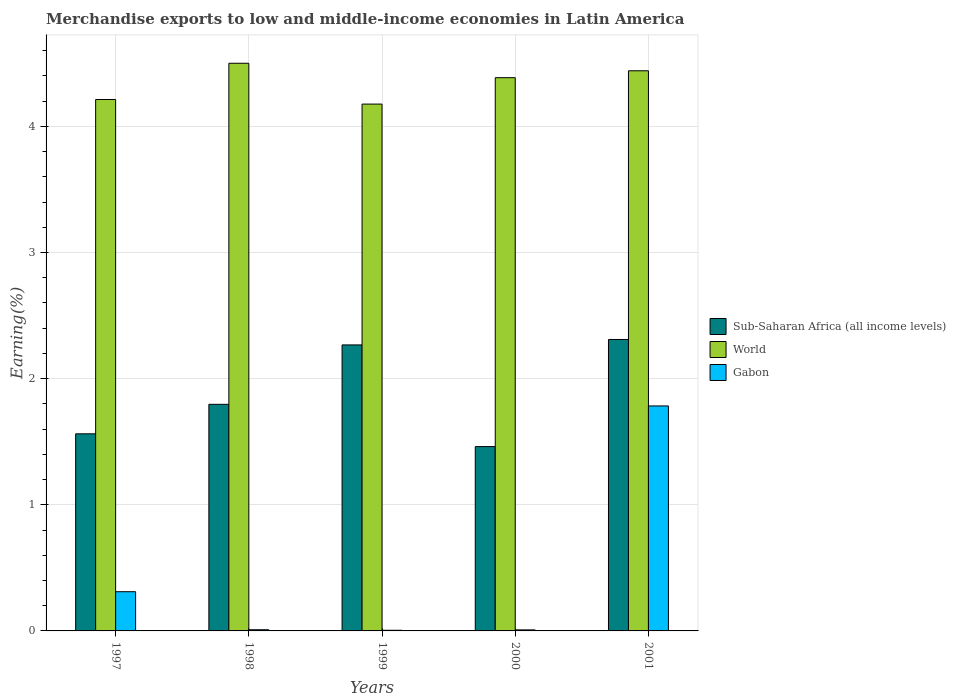How many bars are there on the 2nd tick from the left?
Keep it short and to the point. 3. What is the percentage of amount earned from merchandise exports in Sub-Saharan Africa (all income levels) in 1997?
Offer a terse response. 1.56. Across all years, what is the maximum percentage of amount earned from merchandise exports in World?
Provide a succinct answer. 4.5. Across all years, what is the minimum percentage of amount earned from merchandise exports in Gabon?
Your answer should be very brief. 0.01. In which year was the percentage of amount earned from merchandise exports in World maximum?
Ensure brevity in your answer.  1998. What is the total percentage of amount earned from merchandise exports in World in the graph?
Your answer should be very brief. 21.72. What is the difference between the percentage of amount earned from merchandise exports in World in 1998 and that in 2001?
Provide a succinct answer. 0.06. What is the difference between the percentage of amount earned from merchandise exports in Sub-Saharan Africa (all income levels) in 1998 and the percentage of amount earned from merchandise exports in Gabon in 1999?
Your answer should be compact. 1.79. What is the average percentage of amount earned from merchandise exports in Sub-Saharan Africa (all income levels) per year?
Your answer should be compact. 1.88. In the year 2001, what is the difference between the percentage of amount earned from merchandise exports in Sub-Saharan Africa (all income levels) and percentage of amount earned from merchandise exports in World?
Make the answer very short. -2.13. In how many years, is the percentage of amount earned from merchandise exports in World greater than 1.8 %?
Provide a short and direct response. 5. What is the ratio of the percentage of amount earned from merchandise exports in World in 2000 to that in 2001?
Keep it short and to the point. 0.99. Is the percentage of amount earned from merchandise exports in World in 1999 less than that in 2000?
Keep it short and to the point. Yes. What is the difference between the highest and the second highest percentage of amount earned from merchandise exports in World?
Make the answer very short. 0.06. What is the difference between the highest and the lowest percentage of amount earned from merchandise exports in World?
Offer a terse response. 0.32. Is the sum of the percentage of amount earned from merchandise exports in Gabon in 1998 and 1999 greater than the maximum percentage of amount earned from merchandise exports in World across all years?
Your answer should be compact. No. What does the 3rd bar from the left in 1999 represents?
Ensure brevity in your answer.  Gabon. What does the 1st bar from the right in 2000 represents?
Offer a very short reply. Gabon. How many years are there in the graph?
Your answer should be very brief. 5. What is the difference between two consecutive major ticks on the Y-axis?
Offer a very short reply. 1. Are the values on the major ticks of Y-axis written in scientific E-notation?
Make the answer very short. No. How are the legend labels stacked?
Provide a short and direct response. Vertical. What is the title of the graph?
Offer a terse response. Merchandise exports to low and middle-income economies in Latin America. Does "Europe(developing only)" appear as one of the legend labels in the graph?
Offer a terse response. No. What is the label or title of the Y-axis?
Make the answer very short. Earning(%). What is the Earning(%) of Sub-Saharan Africa (all income levels) in 1997?
Offer a terse response. 1.56. What is the Earning(%) of World in 1997?
Ensure brevity in your answer.  4.21. What is the Earning(%) of Gabon in 1997?
Ensure brevity in your answer.  0.31. What is the Earning(%) in Sub-Saharan Africa (all income levels) in 1998?
Give a very brief answer. 1.8. What is the Earning(%) of World in 1998?
Your response must be concise. 4.5. What is the Earning(%) of Gabon in 1998?
Provide a short and direct response. 0.01. What is the Earning(%) in Sub-Saharan Africa (all income levels) in 1999?
Give a very brief answer. 2.27. What is the Earning(%) of World in 1999?
Provide a succinct answer. 4.18. What is the Earning(%) in Gabon in 1999?
Your response must be concise. 0.01. What is the Earning(%) of Sub-Saharan Africa (all income levels) in 2000?
Keep it short and to the point. 1.46. What is the Earning(%) in World in 2000?
Ensure brevity in your answer.  4.39. What is the Earning(%) of Gabon in 2000?
Ensure brevity in your answer.  0.01. What is the Earning(%) of Sub-Saharan Africa (all income levels) in 2001?
Your answer should be very brief. 2.31. What is the Earning(%) in World in 2001?
Provide a succinct answer. 4.44. What is the Earning(%) of Gabon in 2001?
Provide a short and direct response. 1.78. Across all years, what is the maximum Earning(%) of Sub-Saharan Africa (all income levels)?
Provide a succinct answer. 2.31. Across all years, what is the maximum Earning(%) of World?
Offer a very short reply. 4.5. Across all years, what is the maximum Earning(%) in Gabon?
Your answer should be compact. 1.78. Across all years, what is the minimum Earning(%) in Sub-Saharan Africa (all income levels)?
Your answer should be compact. 1.46. Across all years, what is the minimum Earning(%) of World?
Your answer should be very brief. 4.18. Across all years, what is the minimum Earning(%) in Gabon?
Your response must be concise. 0.01. What is the total Earning(%) in Sub-Saharan Africa (all income levels) in the graph?
Provide a succinct answer. 9.4. What is the total Earning(%) of World in the graph?
Provide a succinct answer. 21.72. What is the total Earning(%) in Gabon in the graph?
Make the answer very short. 2.12. What is the difference between the Earning(%) of Sub-Saharan Africa (all income levels) in 1997 and that in 1998?
Make the answer very short. -0.23. What is the difference between the Earning(%) in World in 1997 and that in 1998?
Provide a short and direct response. -0.29. What is the difference between the Earning(%) in Gabon in 1997 and that in 1998?
Provide a short and direct response. 0.3. What is the difference between the Earning(%) in Sub-Saharan Africa (all income levels) in 1997 and that in 1999?
Your answer should be very brief. -0.7. What is the difference between the Earning(%) in World in 1997 and that in 1999?
Give a very brief answer. 0.04. What is the difference between the Earning(%) of Gabon in 1997 and that in 1999?
Keep it short and to the point. 0.31. What is the difference between the Earning(%) of Sub-Saharan Africa (all income levels) in 1997 and that in 2000?
Keep it short and to the point. 0.1. What is the difference between the Earning(%) of World in 1997 and that in 2000?
Offer a terse response. -0.17. What is the difference between the Earning(%) in Gabon in 1997 and that in 2000?
Your response must be concise. 0.3. What is the difference between the Earning(%) in Sub-Saharan Africa (all income levels) in 1997 and that in 2001?
Your answer should be compact. -0.75. What is the difference between the Earning(%) of World in 1997 and that in 2001?
Ensure brevity in your answer.  -0.23. What is the difference between the Earning(%) in Gabon in 1997 and that in 2001?
Your answer should be very brief. -1.47. What is the difference between the Earning(%) of Sub-Saharan Africa (all income levels) in 1998 and that in 1999?
Keep it short and to the point. -0.47. What is the difference between the Earning(%) in World in 1998 and that in 1999?
Offer a terse response. 0.32. What is the difference between the Earning(%) of Gabon in 1998 and that in 1999?
Your answer should be very brief. 0. What is the difference between the Earning(%) in Sub-Saharan Africa (all income levels) in 1998 and that in 2000?
Keep it short and to the point. 0.34. What is the difference between the Earning(%) of World in 1998 and that in 2000?
Offer a terse response. 0.11. What is the difference between the Earning(%) in Gabon in 1998 and that in 2000?
Offer a terse response. 0. What is the difference between the Earning(%) in Sub-Saharan Africa (all income levels) in 1998 and that in 2001?
Offer a terse response. -0.51. What is the difference between the Earning(%) in World in 1998 and that in 2001?
Offer a very short reply. 0.06. What is the difference between the Earning(%) of Gabon in 1998 and that in 2001?
Your response must be concise. -1.77. What is the difference between the Earning(%) of Sub-Saharan Africa (all income levels) in 1999 and that in 2000?
Make the answer very short. 0.81. What is the difference between the Earning(%) in World in 1999 and that in 2000?
Provide a succinct answer. -0.21. What is the difference between the Earning(%) of Gabon in 1999 and that in 2000?
Your answer should be compact. -0. What is the difference between the Earning(%) in Sub-Saharan Africa (all income levels) in 1999 and that in 2001?
Make the answer very short. -0.04. What is the difference between the Earning(%) in World in 1999 and that in 2001?
Give a very brief answer. -0.26. What is the difference between the Earning(%) of Gabon in 1999 and that in 2001?
Your answer should be very brief. -1.78. What is the difference between the Earning(%) of Sub-Saharan Africa (all income levels) in 2000 and that in 2001?
Offer a very short reply. -0.85. What is the difference between the Earning(%) of World in 2000 and that in 2001?
Your response must be concise. -0.05. What is the difference between the Earning(%) in Gabon in 2000 and that in 2001?
Provide a succinct answer. -1.78. What is the difference between the Earning(%) in Sub-Saharan Africa (all income levels) in 1997 and the Earning(%) in World in 1998?
Your answer should be compact. -2.94. What is the difference between the Earning(%) of Sub-Saharan Africa (all income levels) in 1997 and the Earning(%) of Gabon in 1998?
Give a very brief answer. 1.55. What is the difference between the Earning(%) of World in 1997 and the Earning(%) of Gabon in 1998?
Your response must be concise. 4.2. What is the difference between the Earning(%) of Sub-Saharan Africa (all income levels) in 1997 and the Earning(%) of World in 1999?
Your answer should be very brief. -2.61. What is the difference between the Earning(%) in Sub-Saharan Africa (all income levels) in 1997 and the Earning(%) in Gabon in 1999?
Your response must be concise. 1.56. What is the difference between the Earning(%) of World in 1997 and the Earning(%) of Gabon in 1999?
Keep it short and to the point. 4.21. What is the difference between the Earning(%) in Sub-Saharan Africa (all income levels) in 1997 and the Earning(%) in World in 2000?
Make the answer very short. -2.82. What is the difference between the Earning(%) of Sub-Saharan Africa (all income levels) in 1997 and the Earning(%) of Gabon in 2000?
Provide a succinct answer. 1.55. What is the difference between the Earning(%) in World in 1997 and the Earning(%) in Gabon in 2000?
Offer a terse response. 4.2. What is the difference between the Earning(%) of Sub-Saharan Africa (all income levels) in 1997 and the Earning(%) of World in 2001?
Give a very brief answer. -2.88. What is the difference between the Earning(%) of Sub-Saharan Africa (all income levels) in 1997 and the Earning(%) of Gabon in 2001?
Keep it short and to the point. -0.22. What is the difference between the Earning(%) of World in 1997 and the Earning(%) of Gabon in 2001?
Keep it short and to the point. 2.43. What is the difference between the Earning(%) of Sub-Saharan Africa (all income levels) in 1998 and the Earning(%) of World in 1999?
Your answer should be very brief. -2.38. What is the difference between the Earning(%) in Sub-Saharan Africa (all income levels) in 1998 and the Earning(%) in Gabon in 1999?
Ensure brevity in your answer.  1.79. What is the difference between the Earning(%) in World in 1998 and the Earning(%) in Gabon in 1999?
Ensure brevity in your answer.  4.5. What is the difference between the Earning(%) in Sub-Saharan Africa (all income levels) in 1998 and the Earning(%) in World in 2000?
Your answer should be very brief. -2.59. What is the difference between the Earning(%) in Sub-Saharan Africa (all income levels) in 1998 and the Earning(%) in Gabon in 2000?
Offer a very short reply. 1.79. What is the difference between the Earning(%) in World in 1998 and the Earning(%) in Gabon in 2000?
Ensure brevity in your answer.  4.49. What is the difference between the Earning(%) in Sub-Saharan Africa (all income levels) in 1998 and the Earning(%) in World in 2001?
Offer a terse response. -2.64. What is the difference between the Earning(%) of Sub-Saharan Africa (all income levels) in 1998 and the Earning(%) of Gabon in 2001?
Offer a terse response. 0.01. What is the difference between the Earning(%) of World in 1998 and the Earning(%) of Gabon in 2001?
Your answer should be compact. 2.72. What is the difference between the Earning(%) in Sub-Saharan Africa (all income levels) in 1999 and the Earning(%) in World in 2000?
Provide a short and direct response. -2.12. What is the difference between the Earning(%) of Sub-Saharan Africa (all income levels) in 1999 and the Earning(%) of Gabon in 2000?
Provide a succinct answer. 2.26. What is the difference between the Earning(%) of World in 1999 and the Earning(%) of Gabon in 2000?
Your answer should be compact. 4.17. What is the difference between the Earning(%) in Sub-Saharan Africa (all income levels) in 1999 and the Earning(%) in World in 2001?
Provide a short and direct response. -2.17. What is the difference between the Earning(%) of Sub-Saharan Africa (all income levels) in 1999 and the Earning(%) of Gabon in 2001?
Your response must be concise. 0.48. What is the difference between the Earning(%) in World in 1999 and the Earning(%) in Gabon in 2001?
Offer a very short reply. 2.39. What is the difference between the Earning(%) in Sub-Saharan Africa (all income levels) in 2000 and the Earning(%) in World in 2001?
Keep it short and to the point. -2.98. What is the difference between the Earning(%) in Sub-Saharan Africa (all income levels) in 2000 and the Earning(%) in Gabon in 2001?
Make the answer very short. -0.32. What is the difference between the Earning(%) of World in 2000 and the Earning(%) of Gabon in 2001?
Ensure brevity in your answer.  2.6. What is the average Earning(%) of Sub-Saharan Africa (all income levels) per year?
Keep it short and to the point. 1.88. What is the average Earning(%) of World per year?
Provide a succinct answer. 4.34. What is the average Earning(%) in Gabon per year?
Keep it short and to the point. 0.42. In the year 1997, what is the difference between the Earning(%) of Sub-Saharan Africa (all income levels) and Earning(%) of World?
Offer a terse response. -2.65. In the year 1997, what is the difference between the Earning(%) of Sub-Saharan Africa (all income levels) and Earning(%) of Gabon?
Offer a very short reply. 1.25. In the year 1997, what is the difference between the Earning(%) of World and Earning(%) of Gabon?
Keep it short and to the point. 3.9. In the year 1998, what is the difference between the Earning(%) in Sub-Saharan Africa (all income levels) and Earning(%) in World?
Offer a very short reply. -2.7. In the year 1998, what is the difference between the Earning(%) of Sub-Saharan Africa (all income levels) and Earning(%) of Gabon?
Make the answer very short. 1.79. In the year 1998, what is the difference between the Earning(%) of World and Earning(%) of Gabon?
Your answer should be very brief. 4.49. In the year 1999, what is the difference between the Earning(%) in Sub-Saharan Africa (all income levels) and Earning(%) in World?
Offer a very short reply. -1.91. In the year 1999, what is the difference between the Earning(%) in Sub-Saharan Africa (all income levels) and Earning(%) in Gabon?
Provide a succinct answer. 2.26. In the year 1999, what is the difference between the Earning(%) of World and Earning(%) of Gabon?
Your response must be concise. 4.17. In the year 2000, what is the difference between the Earning(%) in Sub-Saharan Africa (all income levels) and Earning(%) in World?
Keep it short and to the point. -2.92. In the year 2000, what is the difference between the Earning(%) in Sub-Saharan Africa (all income levels) and Earning(%) in Gabon?
Offer a very short reply. 1.45. In the year 2000, what is the difference between the Earning(%) in World and Earning(%) in Gabon?
Ensure brevity in your answer.  4.38. In the year 2001, what is the difference between the Earning(%) in Sub-Saharan Africa (all income levels) and Earning(%) in World?
Your response must be concise. -2.13. In the year 2001, what is the difference between the Earning(%) of Sub-Saharan Africa (all income levels) and Earning(%) of Gabon?
Provide a short and direct response. 0.53. In the year 2001, what is the difference between the Earning(%) in World and Earning(%) in Gabon?
Your answer should be very brief. 2.66. What is the ratio of the Earning(%) in Sub-Saharan Africa (all income levels) in 1997 to that in 1998?
Your answer should be very brief. 0.87. What is the ratio of the Earning(%) of World in 1997 to that in 1998?
Offer a very short reply. 0.94. What is the ratio of the Earning(%) in Gabon in 1997 to that in 1998?
Your answer should be compact. 33.35. What is the ratio of the Earning(%) in Sub-Saharan Africa (all income levels) in 1997 to that in 1999?
Ensure brevity in your answer.  0.69. What is the ratio of the Earning(%) of World in 1997 to that in 1999?
Your response must be concise. 1.01. What is the ratio of the Earning(%) of Gabon in 1997 to that in 1999?
Your response must be concise. 60.29. What is the ratio of the Earning(%) of Sub-Saharan Africa (all income levels) in 1997 to that in 2000?
Make the answer very short. 1.07. What is the ratio of the Earning(%) in World in 1997 to that in 2000?
Offer a terse response. 0.96. What is the ratio of the Earning(%) of Gabon in 1997 to that in 2000?
Offer a very short reply. 37.9. What is the ratio of the Earning(%) in Sub-Saharan Africa (all income levels) in 1997 to that in 2001?
Provide a succinct answer. 0.68. What is the ratio of the Earning(%) of World in 1997 to that in 2001?
Ensure brevity in your answer.  0.95. What is the ratio of the Earning(%) in Gabon in 1997 to that in 2001?
Offer a terse response. 0.17. What is the ratio of the Earning(%) in Sub-Saharan Africa (all income levels) in 1998 to that in 1999?
Offer a terse response. 0.79. What is the ratio of the Earning(%) in World in 1998 to that in 1999?
Your answer should be compact. 1.08. What is the ratio of the Earning(%) of Gabon in 1998 to that in 1999?
Make the answer very short. 1.81. What is the ratio of the Earning(%) of Sub-Saharan Africa (all income levels) in 1998 to that in 2000?
Your answer should be very brief. 1.23. What is the ratio of the Earning(%) in World in 1998 to that in 2000?
Provide a short and direct response. 1.03. What is the ratio of the Earning(%) of Gabon in 1998 to that in 2000?
Provide a succinct answer. 1.14. What is the ratio of the Earning(%) of Sub-Saharan Africa (all income levels) in 1998 to that in 2001?
Offer a very short reply. 0.78. What is the ratio of the Earning(%) of World in 1998 to that in 2001?
Your answer should be compact. 1.01. What is the ratio of the Earning(%) in Gabon in 1998 to that in 2001?
Make the answer very short. 0.01. What is the ratio of the Earning(%) of Sub-Saharan Africa (all income levels) in 1999 to that in 2000?
Make the answer very short. 1.55. What is the ratio of the Earning(%) in World in 1999 to that in 2000?
Offer a terse response. 0.95. What is the ratio of the Earning(%) in Gabon in 1999 to that in 2000?
Keep it short and to the point. 0.63. What is the ratio of the Earning(%) in Sub-Saharan Africa (all income levels) in 1999 to that in 2001?
Your answer should be compact. 0.98. What is the ratio of the Earning(%) in World in 1999 to that in 2001?
Your response must be concise. 0.94. What is the ratio of the Earning(%) of Gabon in 1999 to that in 2001?
Offer a terse response. 0. What is the ratio of the Earning(%) of Sub-Saharan Africa (all income levels) in 2000 to that in 2001?
Offer a terse response. 0.63. What is the ratio of the Earning(%) in World in 2000 to that in 2001?
Keep it short and to the point. 0.99. What is the ratio of the Earning(%) in Gabon in 2000 to that in 2001?
Your response must be concise. 0. What is the difference between the highest and the second highest Earning(%) in Sub-Saharan Africa (all income levels)?
Give a very brief answer. 0.04. What is the difference between the highest and the second highest Earning(%) of World?
Give a very brief answer. 0.06. What is the difference between the highest and the second highest Earning(%) of Gabon?
Keep it short and to the point. 1.47. What is the difference between the highest and the lowest Earning(%) of Sub-Saharan Africa (all income levels)?
Offer a very short reply. 0.85. What is the difference between the highest and the lowest Earning(%) in World?
Offer a terse response. 0.32. What is the difference between the highest and the lowest Earning(%) in Gabon?
Provide a succinct answer. 1.78. 